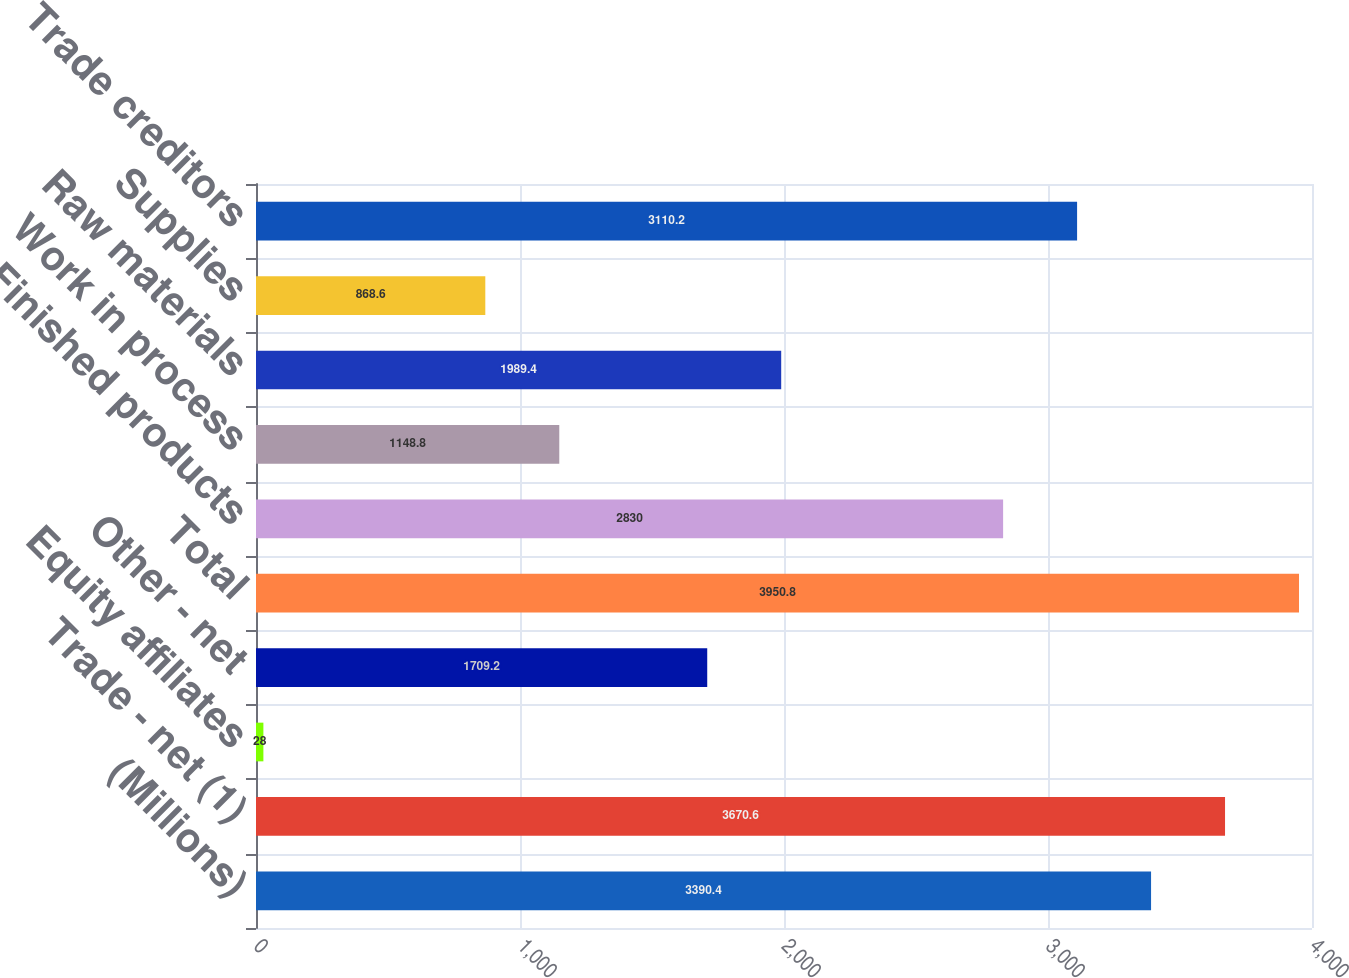Convert chart. <chart><loc_0><loc_0><loc_500><loc_500><bar_chart><fcel>(Millions)<fcel>Trade - net (1)<fcel>Equity affiliates<fcel>Other - net<fcel>Total<fcel>Finished products<fcel>Work in process<fcel>Raw materials<fcel>Supplies<fcel>Trade creditors<nl><fcel>3390.4<fcel>3670.6<fcel>28<fcel>1709.2<fcel>3950.8<fcel>2830<fcel>1148.8<fcel>1989.4<fcel>868.6<fcel>3110.2<nl></chart> 